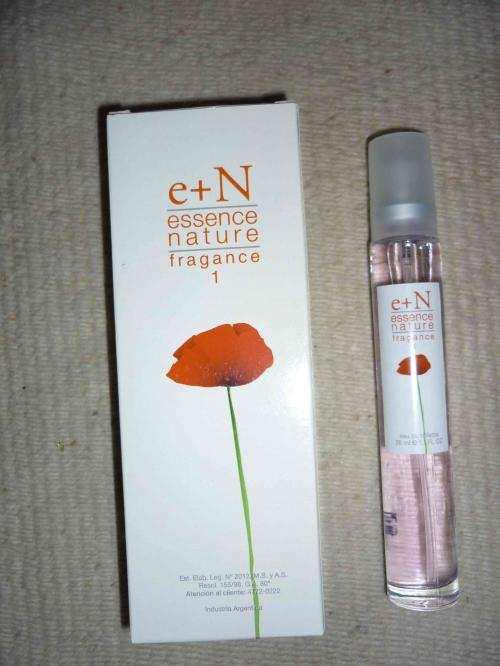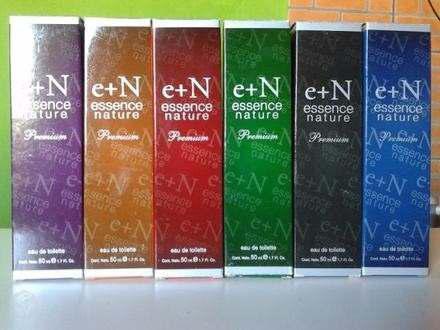The first image is the image on the left, the second image is the image on the right. For the images displayed, is the sentence "One image shows a slender bottle upright next to a box with half of a woman's face on it's front." factually correct? Answer yes or no. No. The first image is the image on the left, the second image is the image on the right. Analyze the images presented: Is the assertion "One of the product boxes has a red flower on the front." valid? Answer yes or no. Yes. 